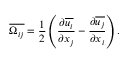Convert formula to latex. <formula><loc_0><loc_0><loc_500><loc_500>\overline { { \Omega _ { i j } } } = \frac { 1 } { 2 } \left ( \frac { \partial \overline { { u _ { i } } } } { \partial x _ { j } } - \frac { \partial \overline { { u _ { j } } } } { \partial x _ { i } } \right ) .</formula> 